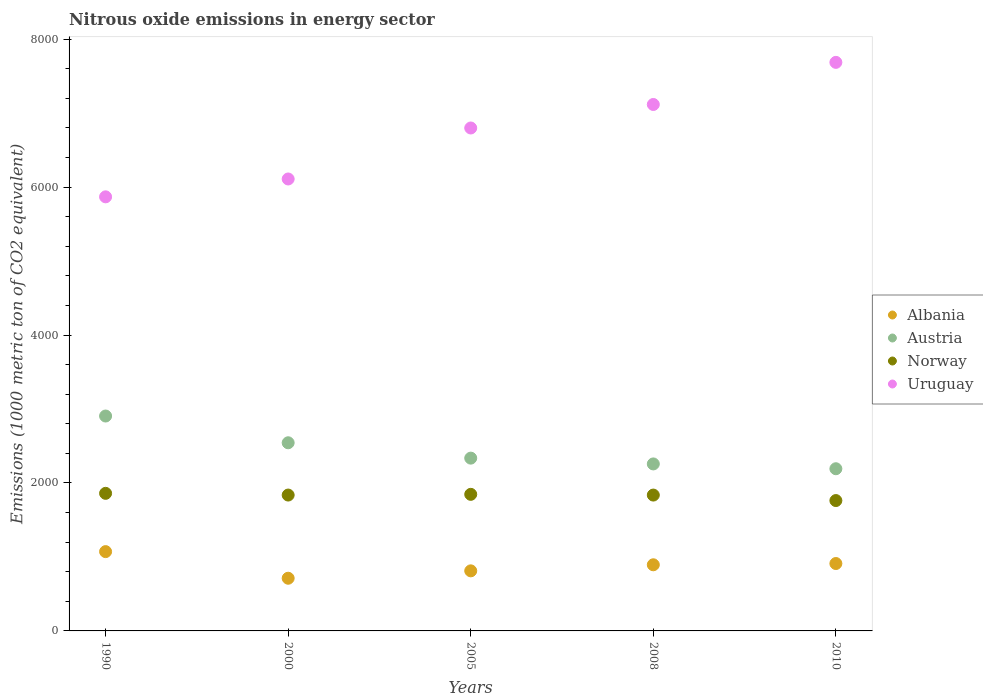What is the amount of nitrous oxide emitted in Uruguay in 1990?
Give a very brief answer. 5867.6. Across all years, what is the maximum amount of nitrous oxide emitted in Austria?
Provide a short and direct response. 2904.8. Across all years, what is the minimum amount of nitrous oxide emitted in Uruguay?
Make the answer very short. 5867.6. In which year was the amount of nitrous oxide emitted in Norway maximum?
Your answer should be very brief. 1990. What is the total amount of nitrous oxide emitted in Uruguay in the graph?
Ensure brevity in your answer.  3.36e+04. What is the difference between the amount of nitrous oxide emitted in Uruguay in 1990 and that in 2010?
Your answer should be compact. -1817.7. What is the difference between the amount of nitrous oxide emitted in Albania in 2000 and the amount of nitrous oxide emitted in Uruguay in 2005?
Your answer should be compact. -6086.1. What is the average amount of nitrous oxide emitted in Norway per year?
Your answer should be compact. 1828.16. In the year 1990, what is the difference between the amount of nitrous oxide emitted in Norway and amount of nitrous oxide emitted in Uruguay?
Keep it short and to the point. -4007.9. In how many years, is the amount of nitrous oxide emitted in Norway greater than 3600 1000 metric ton?
Your answer should be very brief. 0. What is the ratio of the amount of nitrous oxide emitted in Norway in 1990 to that in 2010?
Your answer should be compact. 1.06. Is the amount of nitrous oxide emitted in Austria in 1990 less than that in 2005?
Your answer should be very brief. No. Is the difference between the amount of nitrous oxide emitted in Norway in 1990 and 2010 greater than the difference between the amount of nitrous oxide emitted in Uruguay in 1990 and 2010?
Provide a short and direct response. Yes. What is the difference between the highest and the second highest amount of nitrous oxide emitted in Austria?
Provide a succinct answer. 361.5. What is the difference between the highest and the lowest amount of nitrous oxide emitted in Albania?
Provide a succinct answer. 359.8. Is it the case that in every year, the sum of the amount of nitrous oxide emitted in Austria and amount of nitrous oxide emitted in Uruguay  is greater than the sum of amount of nitrous oxide emitted in Norway and amount of nitrous oxide emitted in Albania?
Give a very brief answer. No. Is the amount of nitrous oxide emitted in Uruguay strictly less than the amount of nitrous oxide emitted in Austria over the years?
Your answer should be compact. No. How many dotlines are there?
Keep it short and to the point. 4. How many years are there in the graph?
Offer a very short reply. 5. Where does the legend appear in the graph?
Ensure brevity in your answer.  Center right. How are the legend labels stacked?
Offer a very short reply. Vertical. What is the title of the graph?
Make the answer very short. Nitrous oxide emissions in energy sector. What is the label or title of the Y-axis?
Offer a very short reply. Emissions (1000 metric ton of CO2 equivalent). What is the Emissions (1000 metric ton of CO2 equivalent) in Albania in 1990?
Your answer should be very brief. 1071.9. What is the Emissions (1000 metric ton of CO2 equivalent) in Austria in 1990?
Provide a short and direct response. 2904.8. What is the Emissions (1000 metric ton of CO2 equivalent) in Norway in 1990?
Provide a short and direct response. 1859.7. What is the Emissions (1000 metric ton of CO2 equivalent) of Uruguay in 1990?
Provide a succinct answer. 5867.6. What is the Emissions (1000 metric ton of CO2 equivalent) of Albania in 2000?
Your answer should be compact. 712.1. What is the Emissions (1000 metric ton of CO2 equivalent) of Austria in 2000?
Make the answer very short. 2543.3. What is the Emissions (1000 metric ton of CO2 equivalent) in Norway in 2000?
Offer a very short reply. 1836.5. What is the Emissions (1000 metric ton of CO2 equivalent) of Uruguay in 2000?
Provide a short and direct response. 6109. What is the Emissions (1000 metric ton of CO2 equivalent) in Albania in 2005?
Your answer should be compact. 812. What is the Emissions (1000 metric ton of CO2 equivalent) of Austria in 2005?
Keep it short and to the point. 2335.7. What is the Emissions (1000 metric ton of CO2 equivalent) of Norway in 2005?
Provide a short and direct response. 1846.2. What is the Emissions (1000 metric ton of CO2 equivalent) of Uruguay in 2005?
Ensure brevity in your answer.  6798.2. What is the Emissions (1000 metric ton of CO2 equivalent) in Albania in 2008?
Your answer should be very brief. 894. What is the Emissions (1000 metric ton of CO2 equivalent) of Austria in 2008?
Provide a short and direct response. 2257.3. What is the Emissions (1000 metric ton of CO2 equivalent) of Norway in 2008?
Keep it short and to the point. 1836.3. What is the Emissions (1000 metric ton of CO2 equivalent) of Uruguay in 2008?
Ensure brevity in your answer.  7116. What is the Emissions (1000 metric ton of CO2 equivalent) of Albania in 2010?
Keep it short and to the point. 911. What is the Emissions (1000 metric ton of CO2 equivalent) in Austria in 2010?
Offer a terse response. 2192.3. What is the Emissions (1000 metric ton of CO2 equivalent) of Norway in 2010?
Your response must be concise. 1762.1. What is the Emissions (1000 metric ton of CO2 equivalent) in Uruguay in 2010?
Ensure brevity in your answer.  7685.3. Across all years, what is the maximum Emissions (1000 metric ton of CO2 equivalent) of Albania?
Your response must be concise. 1071.9. Across all years, what is the maximum Emissions (1000 metric ton of CO2 equivalent) in Austria?
Offer a very short reply. 2904.8. Across all years, what is the maximum Emissions (1000 metric ton of CO2 equivalent) in Norway?
Provide a short and direct response. 1859.7. Across all years, what is the maximum Emissions (1000 metric ton of CO2 equivalent) of Uruguay?
Keep it short and to the point. 7685.3. Across all years, what is the minimum Emissions (1000 metric ton of CO2 equivalent) in Albania?
Provide a succinct answer. 712.1. Across all years, what is the minimum Emissions (1000 metric ton of CO2 equivalent) in Austria?
Make the answer very short. 2192.3. Across all years, what is the minimum Emissions (1000 metric ton of CO2 equivalent) in Norway?
Offer a very short reply. 1762.1. Across all years, what is the minimum Emissions (1000 metric ton of CO2 equivalent) in Uruguay?
Offer a very short reply. 5867.6. What is the total Emissions (1000 metric ton of CO2 equivalent) of Albania in the graph?
Make the answer very short. 4401. What is the total Emissions (1000 metric ton of CO2 equivalent) in Austria in the graph?
Offer a very short reply. 1.22e+04. What is the total Emissions (1000 metric ton of CO2 equivalent) in Norway in the graph?
Your answer should be very brief. 9140.8. What is the total Emissions (1000 metric ton of CO2 equivalent) in Uruguay in the graph?
Make the answer very short. 3.36e+04. What is the difference between the Emissions (1000 metric ton of CO2 equivalent) in Albania in 1990 and that in 2000?
Offer a terse response. 359.8. What is the difference between the Emissions (1000 metric ton of CO2 equivalent) in Austria in 1990 and that in 2000?
Your answer should be very brief. 361.5. What is the difference between the Emissions (1000 metric ton of CO2 equivalent) of Norway in 1990 and that in 2000?
Your response must be concise. 23.2. What is the difference between the Emissions (1000 metric ton of CO2 equivalent) of Uruguay in 1990 and that in 2000?
Offer a very short reply. -241.4. What is the difference between the Emissions (1000 metric ton of CO2 equivalent) of Albania in 1990 and that in 2005?
Your answer should be very brief. 259.9. What is the difference between the Emissions (1000 metric ton of CO2 equivalent) of Austria in 1990 and that in 2005?
Keep it short and to the point. 569.1. What is the difference between the Emissions (1000 metric ton of CO2 equivalent) in Norway in 1990 and that in 2005?
Make the answer very short. 13.5. What is the difference between the Emissions (1000 metric ton of CO2 equivalent) in Uruguay in 1990 and that in 2005?
Offer a terse response. -930.6. What is the difference between the Emissions (1000 metric ton of CO2 equivalent) of Albania in 1990 and that in 2008?
Make the answer very short. 177.9. What is the difference between the Emissions (1000 metric ton of CO2 equivalent) of Austria in 1990 and that in 2008?
Your answer should be very brief. 647.5. What is the difference between the Emissions (1000 metric ton of CO2 equivalent) of Norway in 1990 and that in 2008?
Provide a short and direct response. 23.4. What is the difference between the Emissions (1000 metric ton of CO2 equivalent) of Uruguay in 1990 and that in 2008?
Your answer should be very brief. -1248.4. What is the difference between the Emissions (1000 metric ton of CO2 equivalent) in Albania in 1990 and that in 2010?
Offer a very short reply. 160.9. What is the difference between the Emissions (1000 metric ton of CO2 equivalent) of Austria in 1990 and that in 2010?
Provide a short and direct response. 712.5. What is the difference between the Emissions (1000 metric ton of CO2 equivalent) of Norway in 1990 and that in 2010?
Your answer should be compact. 97.6. What is the difference between the Emissions (1000 metric ton of CO2 equivalent) in Uruguay in 1990 and that in 2010?
Your response must be concise. -1817.7. What is the difference between the Emissions (1000 metric ton of CO2 equivalent) in Albania in 2000 and that in 2005?
Provide a short and direct response. -99.9. What is the difference between the Emissions (1000 metric ton of CO2 equivalent) of Austria in 2000 and that in 2005?
Offer a very short reply. 207.6. What is the difference between the Emissions (1000 metric ton of CO2 equivalent) in Norway in 2000 and that in 2005?
Your answer should be compact. -9.7. What is the difference between the Emissions (1000 metric ton of CO2 equivalent) of Uruguay in 2000 and that in 2005?
Your response must be concise. -689.2. What is the difference between the Emissions (1000 metric ton of CO2 equivalent) of Albania in 2000 and that in 2008?
Offer a very short reply. -181.9. What is the difference between the Emissions (1000 metric ton of CO2 equivalent) in Austria in 2000 and that in 2008?
Ensure brevity in your answer.  286. What is the difference between the Emissions (1000 metric ton of CO2 equivalent) in Norway in 2000 and that in 2008?
Keep it short and to the point. 0.2. What is the difference between the Emissions (1000 metric ton of CO2 equivalent) of Uruguay in 2000 and that in 2008?
Offer a terse response. -1007. What is the difference between the Emissions (1000 metric ton of CO2 equivalent) in Albania in 2000 and that in 2010?
Your response must be concise. -198.9. What is the difference between the Emissions (1000 metric ton of CO2 equivalent) in Austria in 2000 and that in 2010?
Your answer should be very brief. 351. What is the difference between the Emissions (1000 metric ton of CO2 equivalent) in Norway in 2000 and that in 2010?
Your answer should be very brief. 74.4. What is the difference between the Emissions (1000 metric ton of CO2 equivalent) of Uruguay in 2000 and that in 2010?
Your answer should be compact. -1576.3. What is the difference between the Emissions (1000 metric ton of CO2 equivalent) in Albania in 2005 and that in 2008?
Ensure brevity in your answer.  -82. What is the difference between the Emissions (1000 metric ton of CO2 equivalent) of Austria in 2005 and that in 2008?
Ensure brevity in your answer.  78.4. What is the difference between the Emissions (1000 metric ton of CO2 equivalent) in Uruguay in 2005 and that in 2008?
Give a very brief answer. -317.8. What is the difference between the Emissions (1000 metric ton of CO2 equivalent) in Albania in 2005 and that in 2010?
Provide a succinct answer. -99. What is the difference between the Emissions (1000 metric ton of CO2 equivalent) of Austria in 2005 and that in 2010?
Make the answer very short. 143.4. What is the difference between the Emissions (1000 metric ton of CO2 equivalent) in Norway in 2005 and that in 2010?
Offer a very short reply. 84.1. What is the difference between the Emissions (1000 metric ton of CO2 equivalent) of Uruguay in 2005 and that in 2010?
Your answer should be compact. -887.1. What is the difference between the Emissions (1000 metric ton of CO2 equivalent) in Albania in 2008 and that in 2010?
Your response must be concise. -17. What is the difference between the Emissions (1000 metric ton of CO2 equivalent) of Norway in 2008 and that in 2010?
Ensure brevity in your answer.  74.2. What is the difference between the Emissions (1000 metric ton of CO2 equivalent) in Uruguay in 2008 and that in 2010?
Provide a succinct answer. -569.3. What is the difference between the Emissions (1000 metric ton of CO2 equivalent) in Albania in 1990 and the Emissions (1000 metric ton of CO2 equivalent) in Austria in 2000?
Your answer should be compact. -1471.4. What is the difference between the Emissions (1000 metric ton of CO2 equivalent) in Albania in 1990 and the Emissions (1000 metric ton of CO2 equivalent) in Norway in 2000?
Your response must be concise. -764.6. What is the difference between the Emissions (1000 metric ton of CO2 equivalent) in Albania in 1990 and the Emissions (1000 metric ton of CO2 equivalent) in Uruguay in 2000?
Ensure brevity in your answer.  -5037.1. What is the difference between the Emissions (1000 metric ton of CO2 equivalent) of Austria in 1990 and the Emissions (1000 metric ton of CO2 equivalent) of Norway in 2000?
Ensure brevity in your answer.  1068.3. What is the difference between the Emissions (1000 metric ton of CO2 equivalent) in Austria in 1990 and the Emissions (1000 metric ton of CO2 equivalent) in Uruguay in 2000?
Your response must be concise. -3204.2. What is the difference between the Emissions (1000 metric ton of CO2 equivalent) of Norway in 1990 and the Emissions (1000 metric ton of CO2 equivalent) of Uruguay in 2000?
Make the answer very short. -4249.3. What is the difference between the Emissions (1000 metric ton of CO2 equivalent) in Albania in 1990 and the Emissions (1000 metric ton of CO2 equivalent) in Austria in 2005?
Make the answer very short. -1263.8. What is the difference between the Emissions (1000 metric ton of CO2 equivalent) of Albania in 1990 and the Emissions (1000 metric ton of CO2 equivalent) of Norway in 2005?
Your response must be concise. -774.3. What is the difference between the Emissions (1000 metric ton of CO2 equivalent) in Albania in 1990 and the Emissions (1000 metric ton of CO2 equivalent) in Uruguay in 2005?
Keep it short and to the point. -5726.3. What is the difference between the Emissions (1000 metric ton of CO2 equivalent) of Austria in 1990 and the Emissions (1000 metric ton of CO2 equivalent) of Norway in 2005?
Make the answer very short. 1058.6. What is the difference between the Emissions (1000 metric ton of CO2 equivalent) in Austria in 1990 and the Emissions (1000 metric ton of CO2 equivalent) in Uruguay in 2005?
Give a very brief answer. -3893.4. What is the difference between the Emissions (1000 metric ton of CO2 equivalent) in Norway in 1990 and the Emissions (1000 metric ton of CO2 equivalent) in Uruguay in 2005?
Offer a terse response. -4938.5. What is the difference between the Emissions (1000 metric ton of CO2 equivalent) in Albania in 1990 and the Emissions (1000 metric ton of CO2 equivalent) in Austria in 2008?
Your answer should be very brief. -1185.4. What is the difference between the Emissions (1000 metric ton of CO2 equivalent) in Albania in 1990 and the Emissions (1000 metric ton of CO2 equivalent) in Norway in 2008?
Offer a terse response. -764.4. What is the difference between the Emissions (1000 metric ton of CO2 equivalent) of Albania in 1990 and the Emissions (1000 metric ton of CO2 equivalent) of Uruguay in 2008?
Make the answer very short. -6044.1. What is the difference between the Emissions (1000 metric ton of CO2 equivalent) in Austria in 1990 and the Emissions (1000 metric ton of CO2 equivalent) in Norway in 2008?
Provide a succinct answer. 1068.5. What is the difference between the Emissions (1000 metric ton of CO2 equivalent) in Austria in 1990 and the Emissions (1000 metric ton of CO2 equivalent) in Uruguay in 2008?
Give a very brief answer. -4211.2. What is the difference between the Emissions (1000 metric ton of CO2 equivalent) of Norway in 1990 and the Emissions (1000 metric ton of CO2 equivalent) of Uruguay in 2008?
Keep it short and to the point. -5256.3. What is the difference between the Emissions (1000 metric ton of CO2 equivalent) in Albania in 1990 and the Emissions (1000 metric ton of CO2 equivalent) in Austria in 2010?
Your response must be concise. -1120.4. What is the difference between the Emissions (1000 metric ton of CO2 equivalent) in Albania in 1990 and the Emissions (1000 metric ton of CO2 equivalent) in Norway in 2010?
Your answer should be very brief. -690.2. What is the difference between the Emissions (1000 metric ton of CO2 equivalent) of Albania in 1990 and the Emissions (1000 metric ton of CO2 equivalent) of Uruguay in 2010?
Offer a terse response. -6613.4. What is the difference between the Emissions (1000 metric ton of CO2 equivalent) of Austria in 1990 and the Emissions (1000 metric ton of CO2 equivalent) of Norway in 2010?
Provide a short and direct response. 1142.7. What is the difference between the Emissions (1000 metric ton of CO2 equivalent) of Austria in 1990 and the Emissions (1000 metric ton of CO2 equivalent) of Uruguay in 2010?
Make the answer very short. -4780.5. What is the difference between the Emissions (1000 metric ton of CO2 equivalent) in Norway in 1990 and the Emissions (1000 metric ton of CO2 equivalent) in Uruguay in 2010?
Your response must be concise. -5825.6. What is the difference between the Emissions (1000 metric ton of CO2 equivalent) in Albania in 2000 and the Emissions (1000 metric ton of CO2 equivalent) in Austria in 2005?
Provide a short and direct response. -1623.6. What is the difference between the Emissions (1000 metric ton of CO2 equivalent) of Albania in 2000 and the Emissions (1000 metric ton of CO2 equivalent) of Norway in 2005?
Provide a short and direct response. -1134.1. What is the difference between the Emissions (1000 metric ton of CO2 equivalent) of Albania in 2000 and the Emissions (1000 metric ton of CO2 equivalent) of Uruguay in 2005?
Your answer should be compact. -6086.1. What is the difference between the Emissions (1000 metric ton of CO2 equivalent) in Austria in 2000 and the Emissions (1000 metric ton of CO2 equivalent) in Norway in 2005?
Provide a succinct answer. 697.1. What is the difference between the Emissions (1000 metric ton of CO2 equivalent) in Austria in 2000 and the Emissions (1000 metric ton of CO2 equivalent) in Uruguay in 2005?
Provide a succinct answer. -4254.9. What is the difference between the Emissions (1000 metric ton of CO2 equivalent) in Norway in 2000 and the Emissions (1000 metric ton of CO2 equivalent) in Uruguay in 2005?
Give a very brief answer. -4961.7. What is the difference between the Emissions (1000 metric ton of CO2 equivalent) in Albania in 2000 and the Emissions (1000 metric ton of CO2 equivalent) in Austria in 2008?
Your response must be concise. -1545.2. What is the difference between the Emissions (1000 metric ton of CO2 equivalent) in Albania in 2000 and the Emissions (1000 metric ton of CO2 equivalent) in Norway in 2008?
Your answer should be compact. -1124.2. What is the difference between the Emissions (1000 metric ton of CO2 equivalent) in Albania in 2000 and the Emissions (1000 metric ton of CO2 equivalent) in Uruguay in 2008?
Make the answer very short. -6403.9. What is the difference between the Emissions (1000 metric ton of CO2 equivalent) of Austria in 2000 and the Emissions (1000 metric ton of CO2 equivalent) of Norway in 2008?
Provide a succinct answer. 707. What is the difference between the Emissions (1000 metric ton of CO2 equivalent) in Austria in 2000 and the Emissions (1000 metric ton of CO2 equivalent) in Uruguay in 2008?
Your answer should be very brief. -4572.7. What is the difference between the Emissions (1000 metric ton of CO2 equivalent) in Norway in 2000 and the Emissions (1000 metric ton of CO2 equivalent) in Uruguay in 2008?
Offer a terse response. -5279.5. What is the difference between the Emissions (1000 metric ton of CO2 equivalent) of Albania in 2000 and the Emissions (1000 metric ton of CO2 equivalent) of Austria in 2010?
Your answer should be compact. -1480.2. What is the difference between the Emissions (1000 metric ton of CO2 equivalent) in Albania in 2000 and the Emissions (1000 metric ton of CO2 equivalent) in Norway in 2010?
Your response must be concise. -1050. What is the difference between the Emissions (1000 metric ton of CO2 equivalent) of Albania in 2000 and the Emissions (1000 metric ton of CO2 equivalent) of Uruguay in 2010?
Your response must be concise. -6973.2. What is the difference between the Emissions (1000 metric ton of CO2 equivalent) of Austria in 2000 and the Emissions (1000 metric ton of CO2 equivalent) of Norway in 2010?
Offer a very short reply. 781.2. What is the difference between the Emissions (1000 metric ton of CO2 equivalent) of Austria in 2000 and the Emissions (1000 metric ton of CO2 equivalent) of Uruguay in 2010?
Provide a short and direct response. -5142. What is the difference between the Emissions (1000 metric ton of CO2 equivalent) of Norway in 2000 and the Emissions (1000 metric ton of CO2 equivalent) of Uruguay in 2010?
Ensure brevity in your answer.  -5848.8. What is the difference between the Emissions (1000 metric ton of CO2 equivalent) of Albania in 2005 and the Emissions (1000 metric ton of CO2 equivalent) of Austria in 2008?
Keep it short and to the point. -1445.3. What is the difference between the Emissions (1000 metric ton of CO2 equivalent) in Albania in 2005 and the Emissions (1000 metric ton of CO2 equivalent) in Norway in 2008?
Provide a short and direct response. -1024.3. What is the difference between the Emissions (1000 metric ton of CO2 equivalent) in Albania in 2005 and the Emissions (1000 metric ton of CO2 equivalent) in Uruguay in 2008?
Provide a succinct answer. -6304. What is the difference between the Emissions (1000 metric ton of CO2 equivalent) in Austria in 2005 and the Emissions (1000 metric ton of CO2 equivalent) in Norway in 2008?
Give a very brief answer. 499.4. What is the difference between the Emissions (1000 metric ton of CO2 equivalent) in Austria in 2005 and the Emissions (1000 metric ton of CO2 equivalent) in Uruguay in 2008?
Offer a very short reply. -4780.3. What is the difference between the Emissions (1000 metric ton of CO2 equivalent) in Norway in 2005 and the Emissions (1000 metric ton of CO2 equivalent) in Uruguay in 2008?
Provide a short and direct response. -5269.8. What is the difference between the Emissions (1000 metric ton of CO2 equivalent) of Albania in 2005 and the Emissions (1000 metric ton of CO2 equivalent) of Austria in 2010?
Offer a very short reply. -1380.3. What is the difference between the Emissions (1000 metric ton of CO2 equivalent) in Albania in 2005 and the Emissions (1000 metric ton of CO2 equivalent) in Norway in 2010?
Provide a short and direct response. -950.1. What is the difference between the Emissions (1000 metric ton of CO2 equivalent) in Albania in 2005 and the Emissions (1000 metric ton of CO2 equivalent) in Uruguay in 2010?
Keep it short and to the point. -6873.3. What is the difference between the Emissions (1000 metric ton of CO2 equivalent) in Austria in 2005 and the Emissions (1000 metric ton of CO2 equivalent) in Norway in 2010?
Give a very brief answer. 573.6. What is the difference between the Emissions (1000 metric ton of CO2 equivalent) in Austria in 2005 and the Emissions (1000 metric ton of CO2 equivalent) in Uruguay in 2010?
Keep it short and to the point. -5349.6. What is the difference between the Emissions (1000 metric ton of CO2 equivalent) in Norway in 2005 and the Emissions (1000 metric ton of CO2 equivalent) in Uruguay in 2010?
Offer a very short reply. -5839.1. What is the difference between the Emissions (1000 metric ton of CO2 equivalent) in Albania in 2008 and the Emissions (1000 metric ton of CO2 equivalent) in Austria in 2010?
Make the answer very short. -1298.3. What is the difference between the Emissions (1000 metric ton of CO2 equivalent) in Albania in 2008 and the Emissions (1000 metric ton of CO2 equivalent) in Norway in 2010?
Keep it short and to the point. -868.1. What is the difference between the Emissions (1000 metric ton of CO2 equivalent) of Albania in 2008 and the Emissions (1000 metric ton of CO2 equivalent) of Uruguay in 2010?
Keep it short and to the point. -6791.3. What is the difference between the Emissions (1000 metric ton of CO2 equivalent) of Austria in 2008 and the Emissions (1000 metric ton of CO2 equivalent) of Norway in 2010?
Provide a succinct answer. 495.2. What is the difference between the Emissions (1000 metric ton of CO2 equivalent) in Austria in 2008 and the Emissions (1000 metric ton of CO2 equivalent) in Uruguay in 2010?
Ensure brevity in your answer.  -5428. What is the difference between the Emissions (1000 metric ton of CO2 equivalent) of Norway in 2008 and the Emissions (1000 metric ton of CO2 equivalent) of Uruguay in 2010?
Your response must be concise. -5849. What is the average Emissions (1000 metric ton of CO2 equivalent) in Albania per year?
Offer a terse response. 880.2. What is the average Emissions (1000 metric ton of CO2 equivalent) of Austria per year?
Offer a very short reply. 2446.68. What is the average Emissions (1000 metric ton of CO2 equivalent) in Norway per year?
Offer a very short reply. 1828.16. What is the average Emissions (1000 metric ton of CO2 equivalent) of Uruguay per year?
Give a very brief answer. 6715.22. In the year 1990, what is the difference between the Emissions (1000 metric ton of CO2 equivalent) of Albania and Emissions (1000 metric ton of CO2 equivalent) of Austria?
Provide a short and direct response. -1832.9. In the year 1990, what is the difference between the Emissions (1000 metric ton of CO2 equivalent) of Albania and Emissions (1000 metric ton of CO2 equivalent) of Norway?
Your answer should be very brief. -787.8. In the year 1990, what is the difference between the Emissions (1000 metric ton of CO2 equivalent) in Albania and Emissions (1000 metric ton of CO2 equivalent) in Uruguay?
Your response must be concise. -4795.7. In the year 1990, what is the difference between the Emissions (1000 metric ton of CO2 equivalent) of Austria and Emissions (1000 metric ton of CO2 equivalent) of Norway?
Make the answer very short. 1045.1. In the year 1990, what is the difference between the Emissions (1000 metric ton of CO2 equivalent) in Austria and Emissions (1000 metric ton of CO2 equivalent) in Uruguay?
Keep it short and to the point. -2962.8. In the year 1990, what is the difference between the Emissions (1000 metric ton of CO2 equivalent) in Norway and Emissions (1000 metric ton of CO2 equivalent) in Uruguay?
Your answer should be very brief. -4007.9. In the year 2000, what is the difference between the Emissions (1000 metric ton of CO2 equivalent) in Albania and Emissions (1000 metric ton of CO2 equivalent) in Austria?
Your answer should be compact. -1831.2. In the year 2000, what is the difference between the Emissions (1000 metric ton of CO2 equivalent) of Albania and Emissions (1000 metric ton of CO2 equivalent) of Norway?
Offer a very short reply. -1124.4. In the year 2000, what is the difference between the Emissions (1000 metric ton of CO2 equivalent) of Albania and Emissions (1000 metric ton of CO2 equivalent) of Uruguay?
Offer a very short reply. -5396.9. In the year 2000, what is the difference between the Emissions (1000 metric ton of CO2 equivalent) in Austria and Emissions (1000 metric ton of CO2 equivalent) in Norway?
Provide a succinct answer. 706.8. In the year 2000, what is the difference between the Emissions (1000 metric ton of CO2 equivalent) in Austria and Emissions (1000 metric ton of CO2 equivalent) in Uruguay?
Provide a short and direct response. -3565.7. In the year 2000, what is the difference between the Emissions (1000 metric ton of CO2 equivalent) in Norway and Emissions (1000 metric ton of CO2 equivalent) in Uruguay?
Provide a short and direct response. -4272.5. In the year 2005, what is the difference between the Emissions (1000 metric ton of CO2 equivalent) in Albania and Emissions (1000 metric ton of CO2 equivalent) in Austria?
Your answer should be compact. -1523.7. In the year 2005, what is the difference between the Emissions (1000 metric ton of CO2 equivalent) of Albania and Emissions (1000 metric ton of CO2 equivalent) of Norway?
Make the answer very short. -1034.2. In the year 2005, what is the difference between the Emissions (1000 metric ton of CO2 equivalent) in Albania and Emissions (1000 metric ton of CO2 equivalent) in Uruguay?
Provide a succinct answer. -5986.2. In the year 2005, what is the difference between the Emissions (1000 metric ton of CO2 equivalent) of Austria and Emissions (1000 metric ton of CO2 equivalent) of Norway?
Your response must be concise. 489.5. In the year 2005, what is the difference between the Emissions (1000 metric ton of CO2 equivalent) in Austria and Emissions (1000 metric ton of CO2 equivalent) in Uruguay?
Your answer should be compact. -4462.5. In the year 2005, what is the difference between the Emissions (1000 metric ton of CO2 equivalent) in Norway and Emissions (1000 metric ton of CO2 equivalent) in Uruguay?
Provide a short and direct response. -4952. In the year 2008, what is the difference between the Emissions (1000 metric ton of CO2 equivalent) of Albania and Emissions (1000 metric ton of CO2 equivalent) of Austria?
Your answer should be very brief. -1363.3. In the year 2008, what is the difference between the Emissions (1000 metric ton of CO2 equivalent) in Albania and Emissions (1000 metric ton of CO2 equivalent) in Norway?
Make the answer very short. -942.3. In the year 2008, what is the difference between the Emissions (1000 metric ton of CO2 equivalent) in Albania and Emissions (1000 metric ton of CO2 equivalent) in Uruguay?
Keep it short and to the point. -6222. In the year 2008, what is the difference between the Emissions (1000 metric ton of CO2 equivalent) in Austria and Emissions (1000 metric ton of CO2 equivalent) in Norway?
Your answer should be very brief. 421. In the year 2008, what is the difference between the Emissions (1000 metric ton of CO2 equivalent) of Austria and Emissions (1000 metric ton of CO2 equivalent) of Uruguay?
Provide a succinct answer. -4858.7. In the year 2008, what is the difference between the Emissions (1000 metric ton of CO2 equivalent) in Norway and Emissions (1000 metric ton of CO2 equivalent) in Uruguay?
Ensure brevity in your answer.  -5279.7. In the year 2010, what is the difference between the Emissions (1000 metric ton of CO2 equivalent) in Albania and Emissions (1000 metric ton of CO2 equivalent) in Austria?
Your answer should be very brief. -1281.3. In the year 2010, what is the difference between the Emissions (1000 metric ton of CO2 equivalent) of Albania and Emissions (1000 metric ton of CO2 equivalent) of Norway?
Make the answer very short. -851.1. In the year 2010, what is the difference between the Emissions (1000 metric ton of CO2 equivalent) of Albania and Emissions (1000 metric ton of CO2 equivalent) of Uruguay?
Ensure brevity in your answer.  -6774.3. In the year 2010, what is the difference between the Emissions (1000 metric ton of CO2 equivalent) in Austria and Emissions (1000 metric ton of CO2 equivalent) in Norway?
Make the answer very short. 430.2. In the year 2010, what is the difference between the Emissions (1000 metric ton of CO2 equivalent) in Austria and Emissions (1000 metric ton of CO2 equivalent) in Uruguay?
Your response must be concise. -5493. In the year 2010, what is the difference between the Emissions (1000 metric ton of CO2 equivalent) in Norway and Emissions (1000 metric ton of CO2 equivalent) in Uruguay?
Give a very brief answer. -5923.2. What is the ratio of the Emissions (1000 metric ton of CO2 equivalent) in Albania in 1990 to that in 2000?
Offer a terse response. 1.51. What is the ratio of the Emissions (1000 metric ton of CO2 equivalent) of Austria in 1990 to that in 2000?
Ensure brevity in your answer.  1.14. What is the ratio of the Emissions (1000 metric ton of CO2 equivalent) of Norway in 1990 to that in 2000?
Your answer should be very brief. 1.01. What is the ratio of the Emissions (1000 metric ton of CO2 equivalent) in Uruguay in 1990 to that in 2000?
Ensure brevity in your answer.  0.96. What is the ratio of the Emissions (1000 metric ton of CO2 equivalent) in Albania in 1990 to that in 2005?
Provide a succinct answer. 1.32. What is the ratio of the Emissions (1000 metric ton of CO2 equivalent) in Austria in 1990 to that in 2005?
Provide a short and direct response. 1.24. What is the ratio of the Emissions (1000 metric ton of CO2 equivalent) of Norway in 1990 to that in 2005?
Offer a terse response. 1.01. What is the ratio of the Emissions (1000 metric ton of CO2 equivalent) in Uruguay in 1990 to that in 2005?
Offer a very short reply. 0.86. What is the ratio of the Emissions (1000 metric ton of CO2 equivalent) of Albania in 1990 to that in 2008?
Provide a short and direct response. 1.2. What is the ratio of the Emissions (1000 metric ton of CO2 equivalent) in Austria in 1990 to that in 2008?
Ensure brevity in your answer.  1.29. What is the ratio of the Emissions (1000 metric ton of CO2 equivalent) in Norway in 1990 to that in 2008?
Offer a very short reply. 1.01. What is the ratio of the Emissions (1000 metric ton of CO2 equivalent) in Uruguay in 1990 to that in 2008?
Provide a succinct answer. 0.82. What is the ratio of the Emissions (1000 metric ton of CO2 equivalent) of Albania in 1990 to that in 2010?
Offer a terse response. 1.18. What is the ratio of the Emissions (1000 metric ton of CO2 equivalent) in Austria in 1990 to that in 2010?
Your answer should be compact. 1.32. What is the ratio of the Emissions (1000 metric ton of CO2 equivalent) in Norway in 1990 to that in 2010?
Keep it short and to the point. 1.06. What is the ratio of the Emissions (1000 metric ton of CO2 equivalent) of Uruguay in 1990 to that in 2010?
Provide a short and direct response. 0.76. What is the ratio of the Emissions (1000 metric ton of CO2 equivalent) of Albania in 2000 to that in 2005?
Your answer should be compact. 0.88. What is the ratio of the Emissions (1000 metric ton of CO2 equivalent) in Austria in 2000 to that in 2005?
Your response must be concise. 1.09. What is the ratio of the Emissions (1000 metric ton of CO2 equivalent) of Uruguay in 2000 to that in 2005?
Ensure brevity in your answer.  0.9. What is the ratio of the Emissions (1000 metric ton of CO2 equivalent) in Albania in 2000 to that in 2008?
Offer a terse response. 0.8. What is the ratio of the Emissions (1000 metric ton of CO2 equivalent) of Austria in 2000 to that in 2008?
Your answer should be very brief. 1.13. What is the ratio of the Emissions (1000 metric ton of CO2 equivalent) of Uruguay in 2000 to that in 2008?
Give a very brief answer. 0.86. What is the ratio of the Emissions (1000 metric ton of CO2 equivalent) of Albania in 2000 to that in 2010?
Provide a short and direct response. 0.78. What is the ratio of the Emissions (1000 metric ton of CO2 equivalent) of Austria in 2000 to that in 2010?
Provide a short and direct response. 1.16. What is the ratio of the Emissions (1000 metric ton of CO2 equivalent) of Norway in 2000 to that in 2010?
Your answer should be compact. 1.04. What is the ratio of the Emissions (1000 metric ton of CO2 equivalent) in Uruguay in 2000 to that in 2010?
Your answer should be very brief. 0.79. What is the ratio of the Emissions (1000 metric ton of CO2 equivalent) in Albania in 2005 to that in 2008?
Provide a succinct answer. 0.91. What is the ratio of the Emissions (1000 metric ton of CO2 equivalent) in Austria in 2005 to that in 2008?
Offer a very short reply. 1.03. What is the ratio of the Emissions (1000 metric ton of CO2 equivalent) in Norway in 2005 to that in 2008?
Keep it short and to the point. 1.01. What is the ratio of the Emissions (1000 metric ton of CO2 equivalent) in Uruguay in 2005 to that in 2008?
Offer a very short reply. 0.96. What is the ratio of the Emissions (1000 metric ton of CO2 equivalent) of Albania in 2005 to that in 2010?
Provide a succinct answer. 0.89. What is the ratio of the Emissions (1000 metric ton of CO2 equivalent) in Austria in 2005 to that in 2010?
Ensure brevity in your answer.  1.07. What is the ratio of the Emissions (1000 metric ton of CO2 equivalent) in Norway in 2005 to that in 2010?
Your response must be concise. 1.05. What is the ratio of the Emissions (1000 metric ton of CO2 equivalent) of Uruguay in 2005 to that in 2010?
Give a very brief answer. 0.88. What is the ratio of the Emissions (1000 metric ton of CO2 equivalent) in Albania in 2008 to that in 2010?
Offer a very short reply. 0.98. What is the ratio of the Emissions (1000 metric ton of CO2 equivalent) in Austria in 2008 to that in 2010?
Your response must be concise. 1.03. What is the ratio of the Emissions (1000 metric ton of CO2 equivalent) of Norway in 2008 to that in 2010?
Offer a terse response. 1.04. What is the ratio of the Emissions (1000 metric ton of CO2 equivalent) of Uruguay in 2008 to that in 2010?
Give a very brief answer. 0.93. What is the difference between the highest and the second highest Emissions (1000 metric ton of CO2 equivalent) of Albania?
Your answer should be very brief. 160.9. What is the difference between the highest and the second highest Emissions (1000 metric ton of CO2 equivalent) of Austria?
Keep it short and to the point. 361.5. What is the difference between the highest and the second highest Emissions (1000 metric ton of CO2 equivalent) of Uruguay?
Provide a succinct answer. 569.3. What is the difference between the highest and the lowest Emissions (1000 metric ton of CO2 equivalent) in Albania?
Give a very brief answer. 359.8. What is the difference between the highest and the lowest Emissions (1000 metric ton of CO2 equivalent) in Austria?
Keep it short and to the point. 712.5. What is the difference between the highest and the lowest Emissions (1000 metric ton of CO2 equivalent) of Norway?
Give a very brief answer. 97.6. What is the difference between the highest and the lowest Emissions (1000 metric ton of CO2 equivalent) in Uruguay?
Provide a succinct answer. 1817.7. 